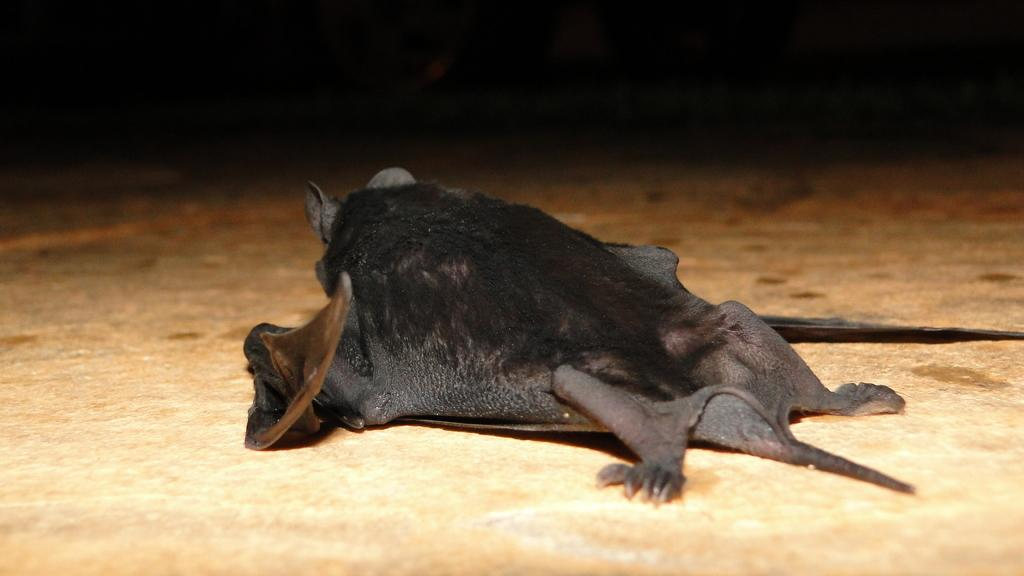What animal is present in the image? There is a bat in the image. Where is the bat located in the image? The bat is on the floor. How many brothers does the bat have in the image? There is no information about the bat's family or siblings in the image. What type of volleyball game is being played in the image? There is no volleyball game or any reference to volleyball in the image. 